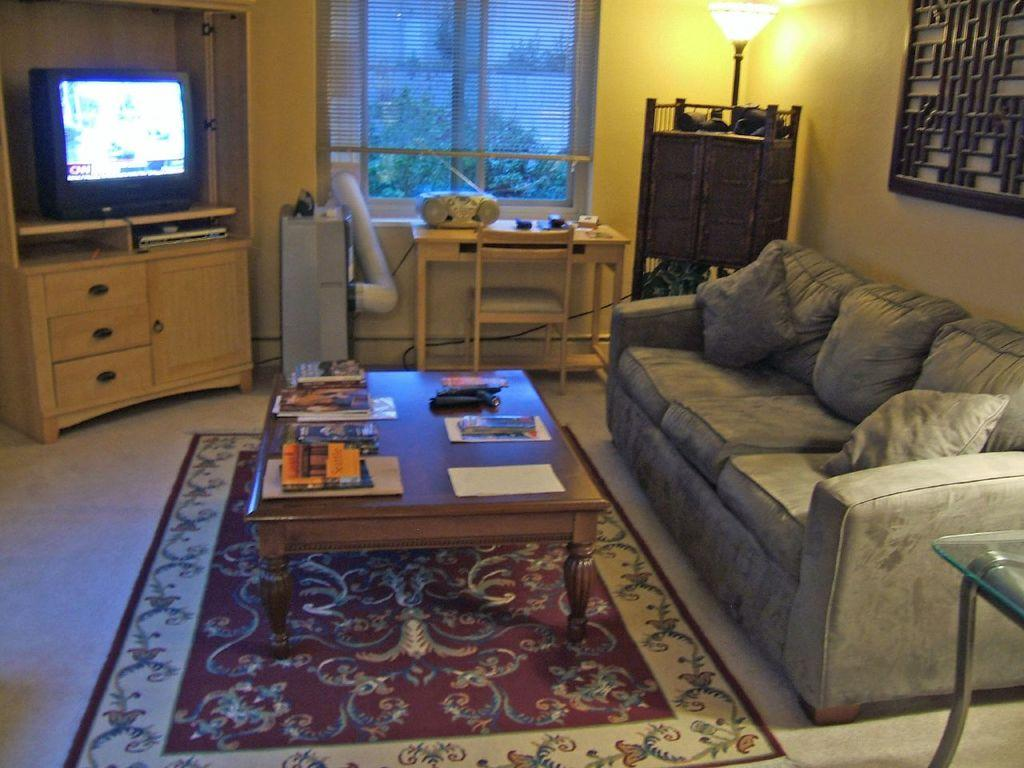What electronic device is visible in the image? There is a television in the image. What type of furniture is present in the image? There is a desk, a table, and a sofa in the image. What is the purpose of the lamp in the image? The lamp is likely used for providing light in the room. What is the purpose of the tape recorder in the image? The tape recorder is likely used for recording or playing audio. What is on the table in the image? There are items on the table, but the specific items are not mentioned in the facts. What is the pillow used for in the image? The pillow is likely used for providing comfort or support while sitting or lying down. What is the glass used for in the image? The glass is likely used for holding a beverage or other liquid. How does the dirt affect the acoustics of the room in the image? There is no mention of dirt in the image, so it cannot be determined how it might affect the acoustics of the room. 